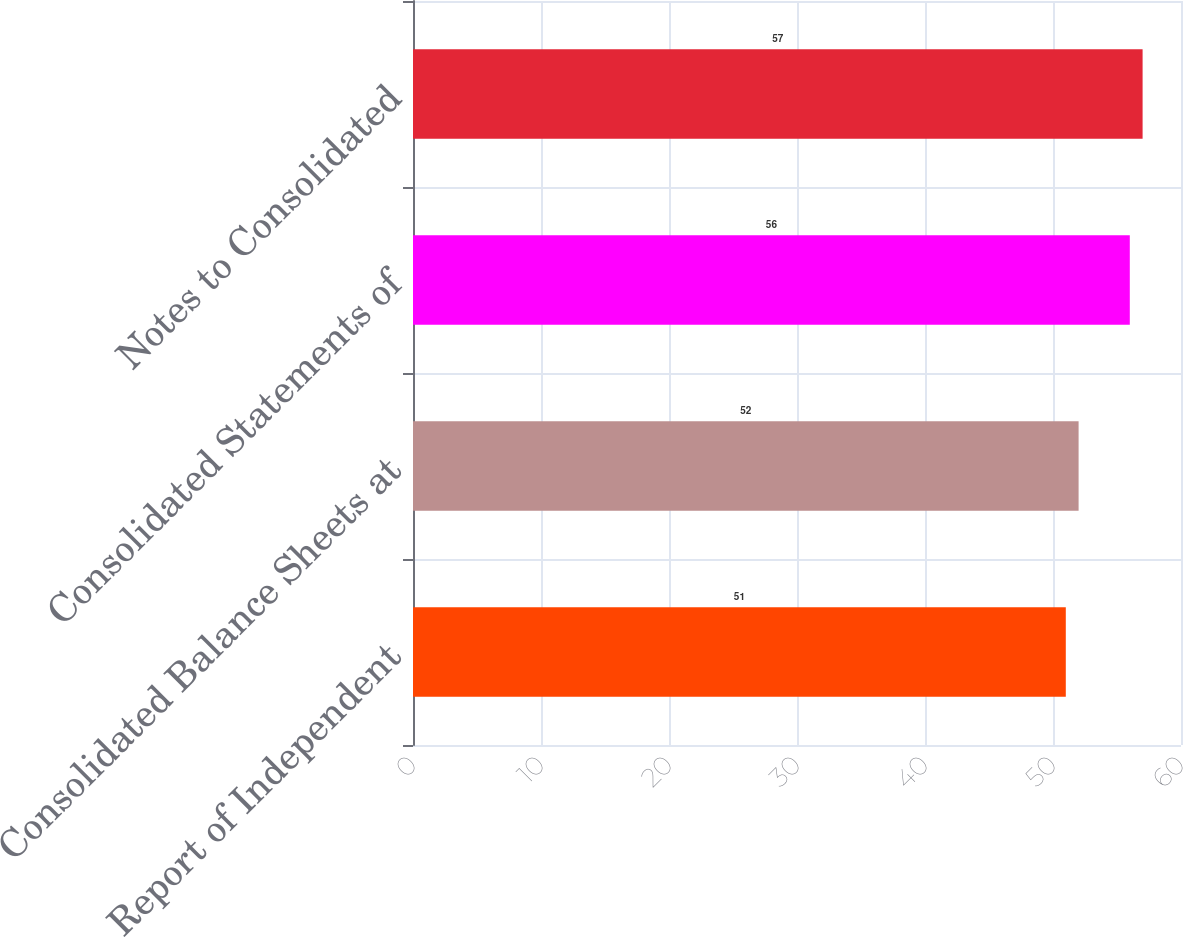Convert chart. <chart><loc_0><loc_0><loc_500><loc_500><bar_chart><fcel>Report of Independent<fcel>Consolidated Balance Sheets at<fcel>Consolidated Statements of<fcel>Notes to Consolidated<nl><fcel>51<fcel>52<fcel>56<fcel>57<nl></chart> 